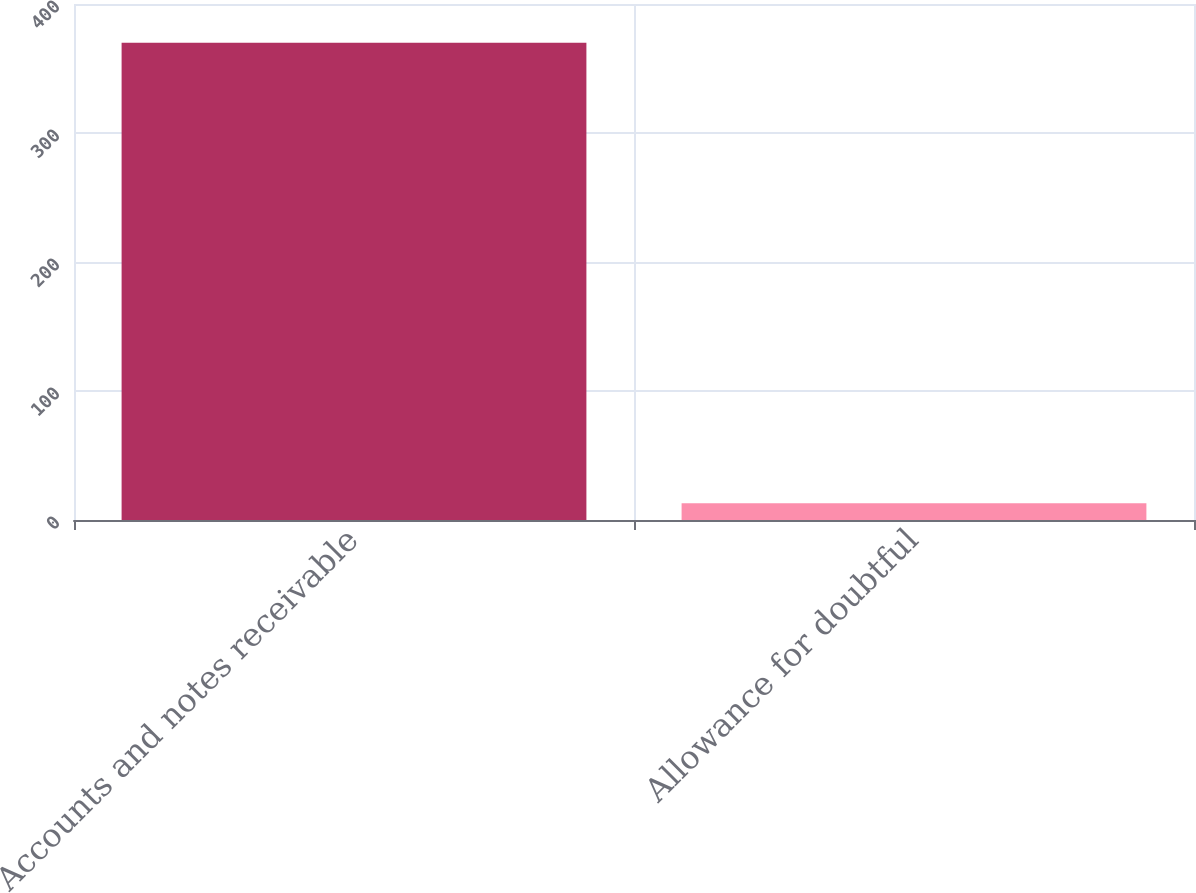Convert chart to OTSL. <chart><loc_0><loc_0><loc_500><loc_500><bar_chart><fcel>Accounts and notes receivable<fcel>Allowance for doubtful<nl><fcel>370<fcel>13<nl></chart> 